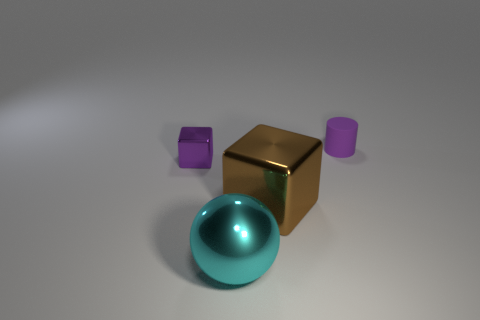Add 3 large blue matte balls. How many objects exist? 7 Subtract all spheres. How many objects are left? 3 Subtract 0 blue balls. How many objects are left? 4 Subtract all big gray cubes. Subtract all large metallic spheres. How many objects are left? 3 Add 2 rubber things. How many rubber things are left? 3 Add 4 big cyan metallic objects. How many big cyan metallic objects exist? 5 